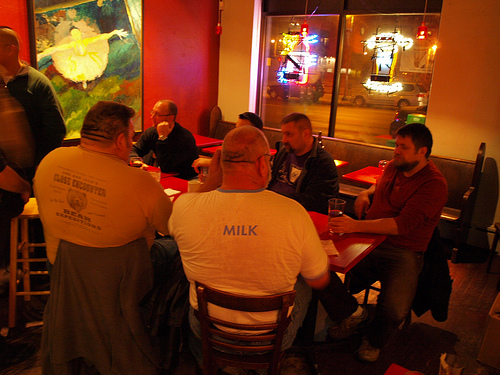<image>
Is there a man on the chair? Yes. Looking at the image, I can see the man is positioned on top of the chair, with the chair providing support. Is there a shirt on the man? No. The shirt is not positioned on the man. They may be near each other, but the shirt is not supported by or resting on top of the man. Is there a man behind the table? No. The man is not behind the table. From this viewpoint, the man appears to be positioned elsewhere in the scene. 